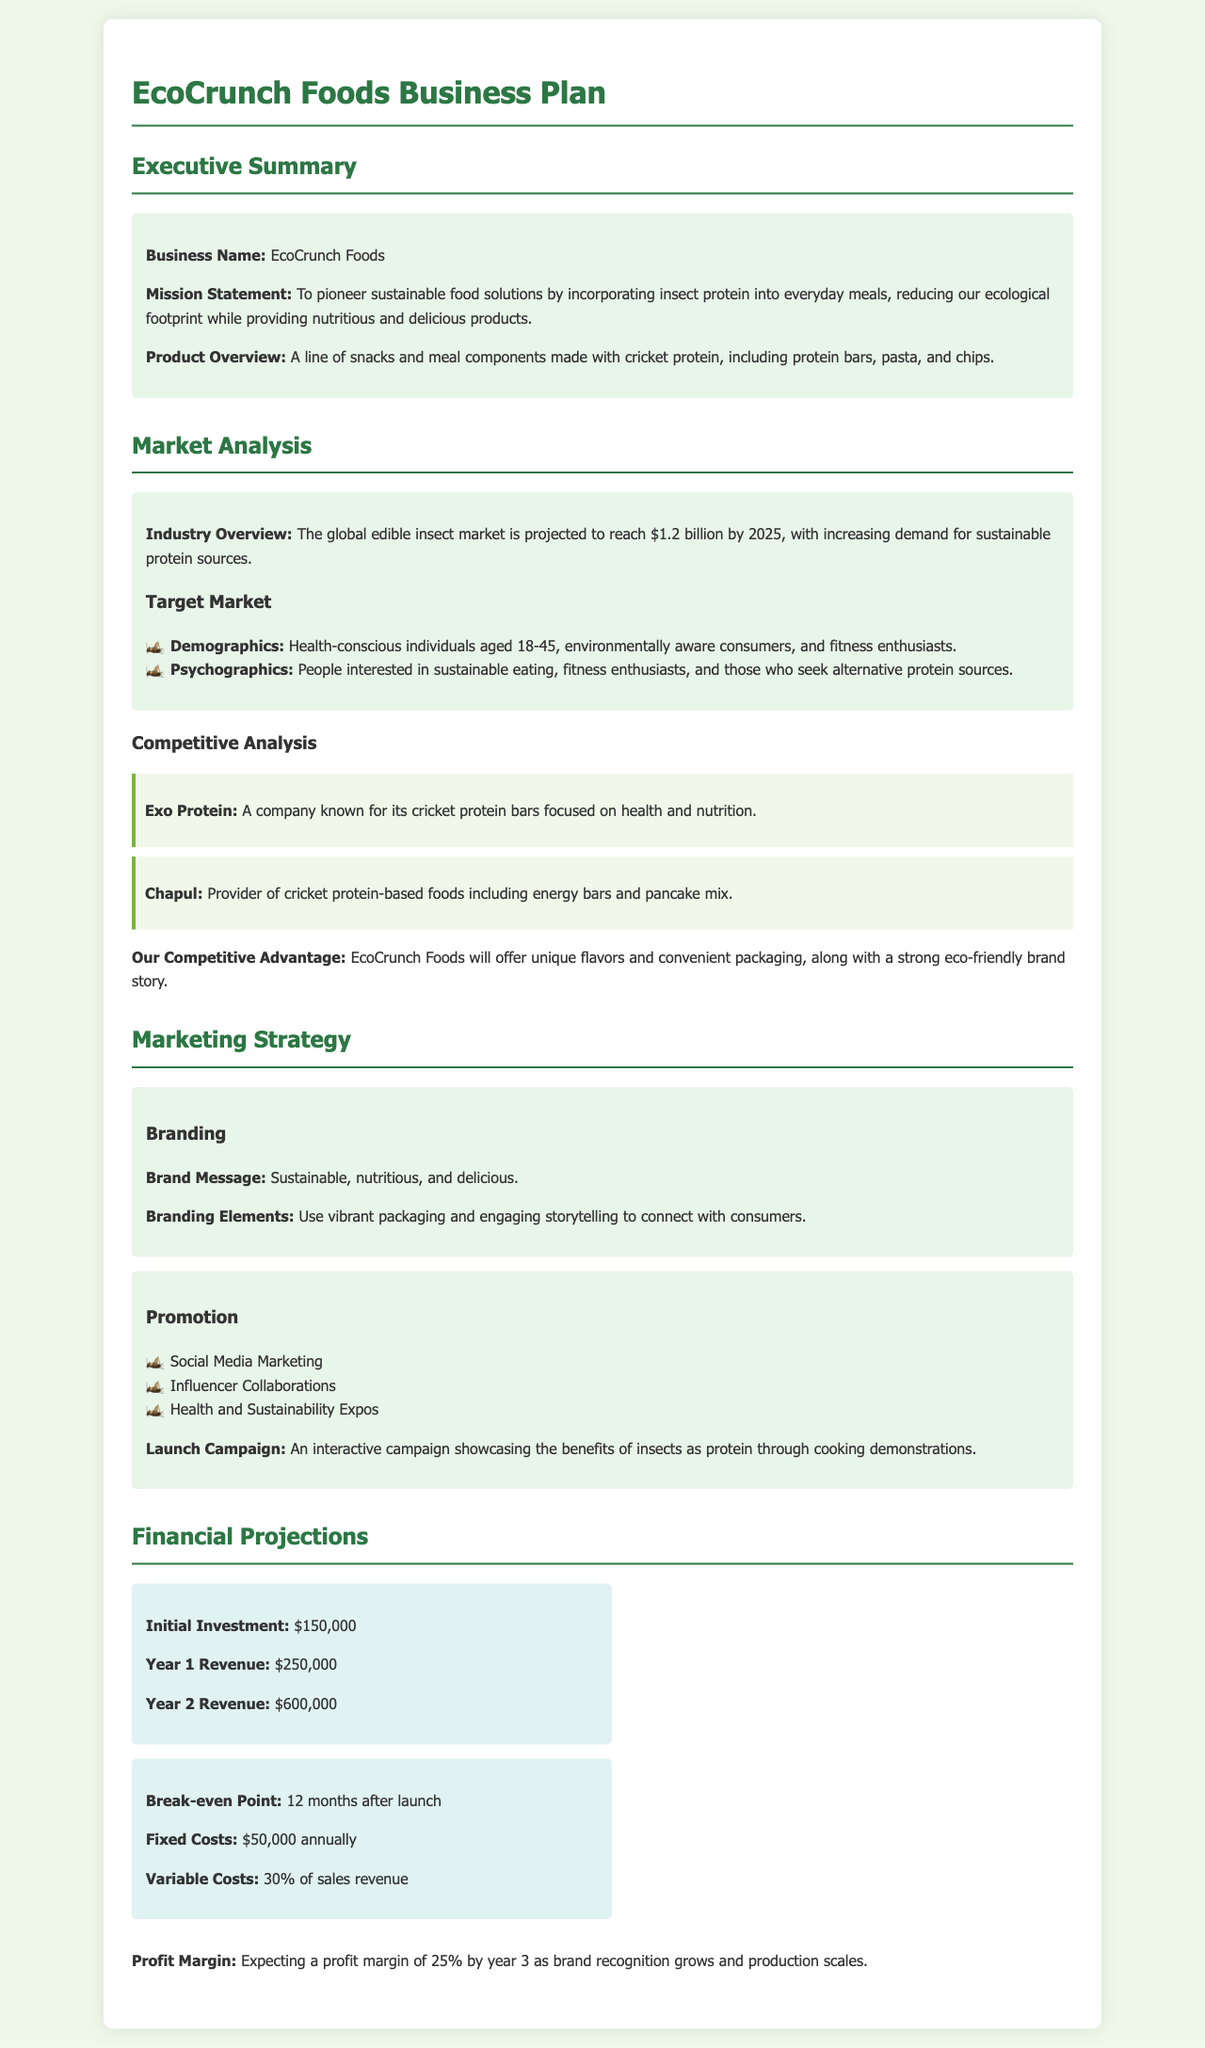What is the business name? The business name is specified in the Executive Summary section of the document.
Answer: EcoCrunch Foods What is the mission statement? The mission statement outlines the purpose of the business and is found in the Executive Summary.
Answer: To pioneer sustainable food solutions by incorporating insect protein into everyday meals, reducing our ecological footprint while providing nutritious and delicious products What is the initial investment amount? This amount is listed in the Financial Projections section under the financial details.
Answer: $150,000 What is the projected Year 1 revenue? This figure is provided in the Financial Projections section for the first year of operations.
Answer: $250,000 Who is a competitor mentioned in the document? The document provides names of competitors in the Competitive Analysis section.
Answer: Exo Protein What is the expected profit margin by year 3? This expectation is stated in the Financial Projections section of the document.
Answer: 25% What is the target demographic for the product? This information can be found in the Market Analysis section regarding the target market.
Answer: Health-conscious individuals aged 18-45 What is the break-even point timeframe? The specific timeframe for reaching the break-even point is noted in the Financial Projections.
Answer: 12 months after launch What types of products will EcoCrunch Foods offer? The product overview in the Executive Summary describes the types of products offered.
Answer: Snacks and meal components made with cricket protein What is the marketing strategy for brand promotion? The document lists several promotional strategies in the Marketing Strategy section.
Answer: Social Media Marketing 